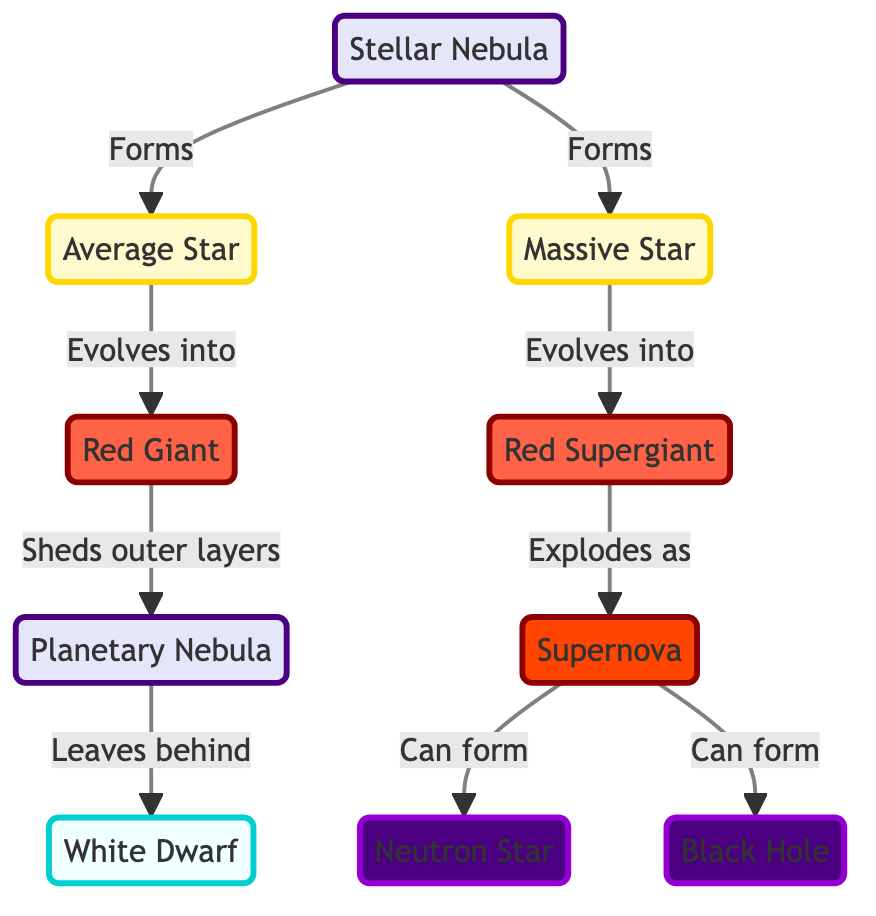What is the first stage in the lifecycle of a star? The diagram indicates that the lifecycle begins with a Stellar Nebula as the initial stage. This is the first node in the diagram, from which all other stages originate.
Answer: Stellar Nebula How many types of stars are shown in the diagram? The diagram features three types of stars: Average Star, Massive Star, and Red Giant. The counting involves the distinct star nodes present in the diagram, summing them up yields three types.
Answer: Three What forms after the Average Star evolves? After the Average Star evolves, it transforms into a Red Giant, as indicated by a direct relationship arrow in the diagram. This shows the progression from Average Star to its evolved form.
Answer: Red Giant What happens to a Massive Star after reaching the Red Supergiant stage? The diagram states that a Massive Star evolves into a Red Supergiant. After this stage, it explodes as a Supernova, revealing that the Red Supergiant is a precursor to the Supernova.
Answer: Explodes as Supernova What two celestial objects can form from a Supernova? From the Supernova stage, the diagram indicates two possible outcomes: it can form either a Neutron Star or a Black Hole. This is verified by the two arrows leading away from the Supernova node towards these two end states.
Answer: Neutron Star or Black Hole What comes after the Red Giant phase? In the diagram, after the Red Giant phase, the star sheds its outer layers to become a Planetary Nebula. This relationship clearly connects the Red Giant with its resulting phase.
Answer: Planetary Nebula How does the lifecycle of an Average Star differ from a Massive Star? The Average Star evolves into a Red Giant and then to a Planetary Nebula, while the Massive Star evolves into a Red Supergiant and subsequently explodes as a Supernova. Thus, the paths and resulting end states differ significantly.
Answer: Different evolutionary paths What does a Planetary Nebula leave behind? The diagram reveals that a Planetary Nebula leaves behind a White Dwarf, showing the final remnant state of an Average Star after its lifecycle process.
Answer: White Dwarf 